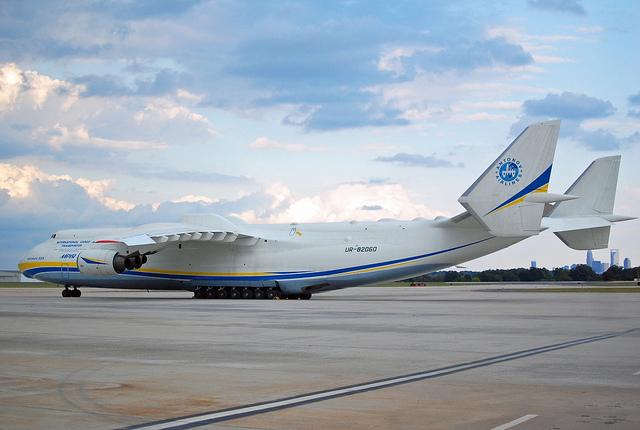Is this your average commercial liner?
Short answer required. No. Is the airplane facing left or right in this scene?
Quick response, please. Left. What airline does the airplane belong to?
Be succinct. Aeroflot. 